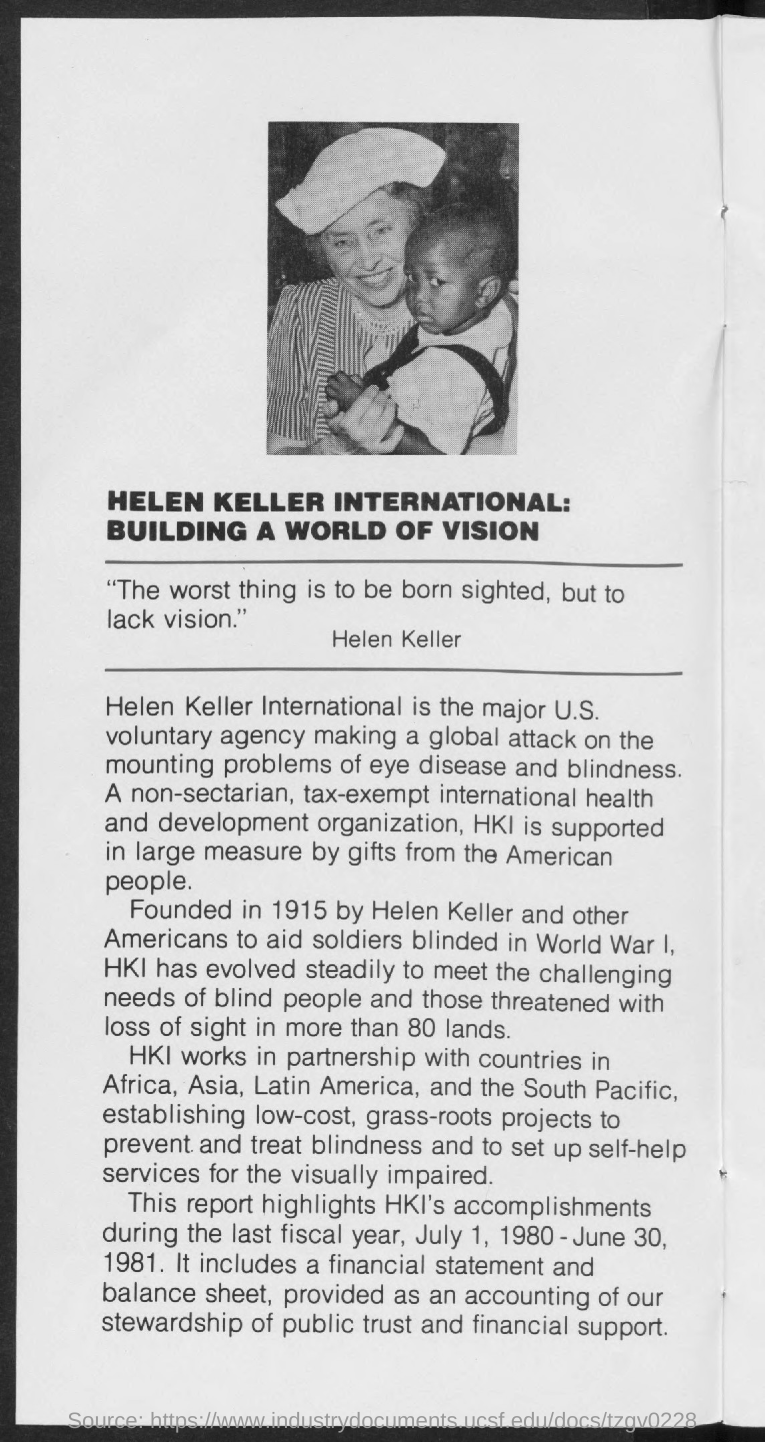What is the quote given by Helen Keller in this document?
Provide a succinct answer. "The worst thing is to be born sighted, but to lack vision". The highlights of HKI's accomplishments were reported of which time period?
Keep it short and to the point. July 1, 1980 - June 30, 1981. By which people is the HKI supported in large measure by gifts?
Your answer should be very brief. American people. 